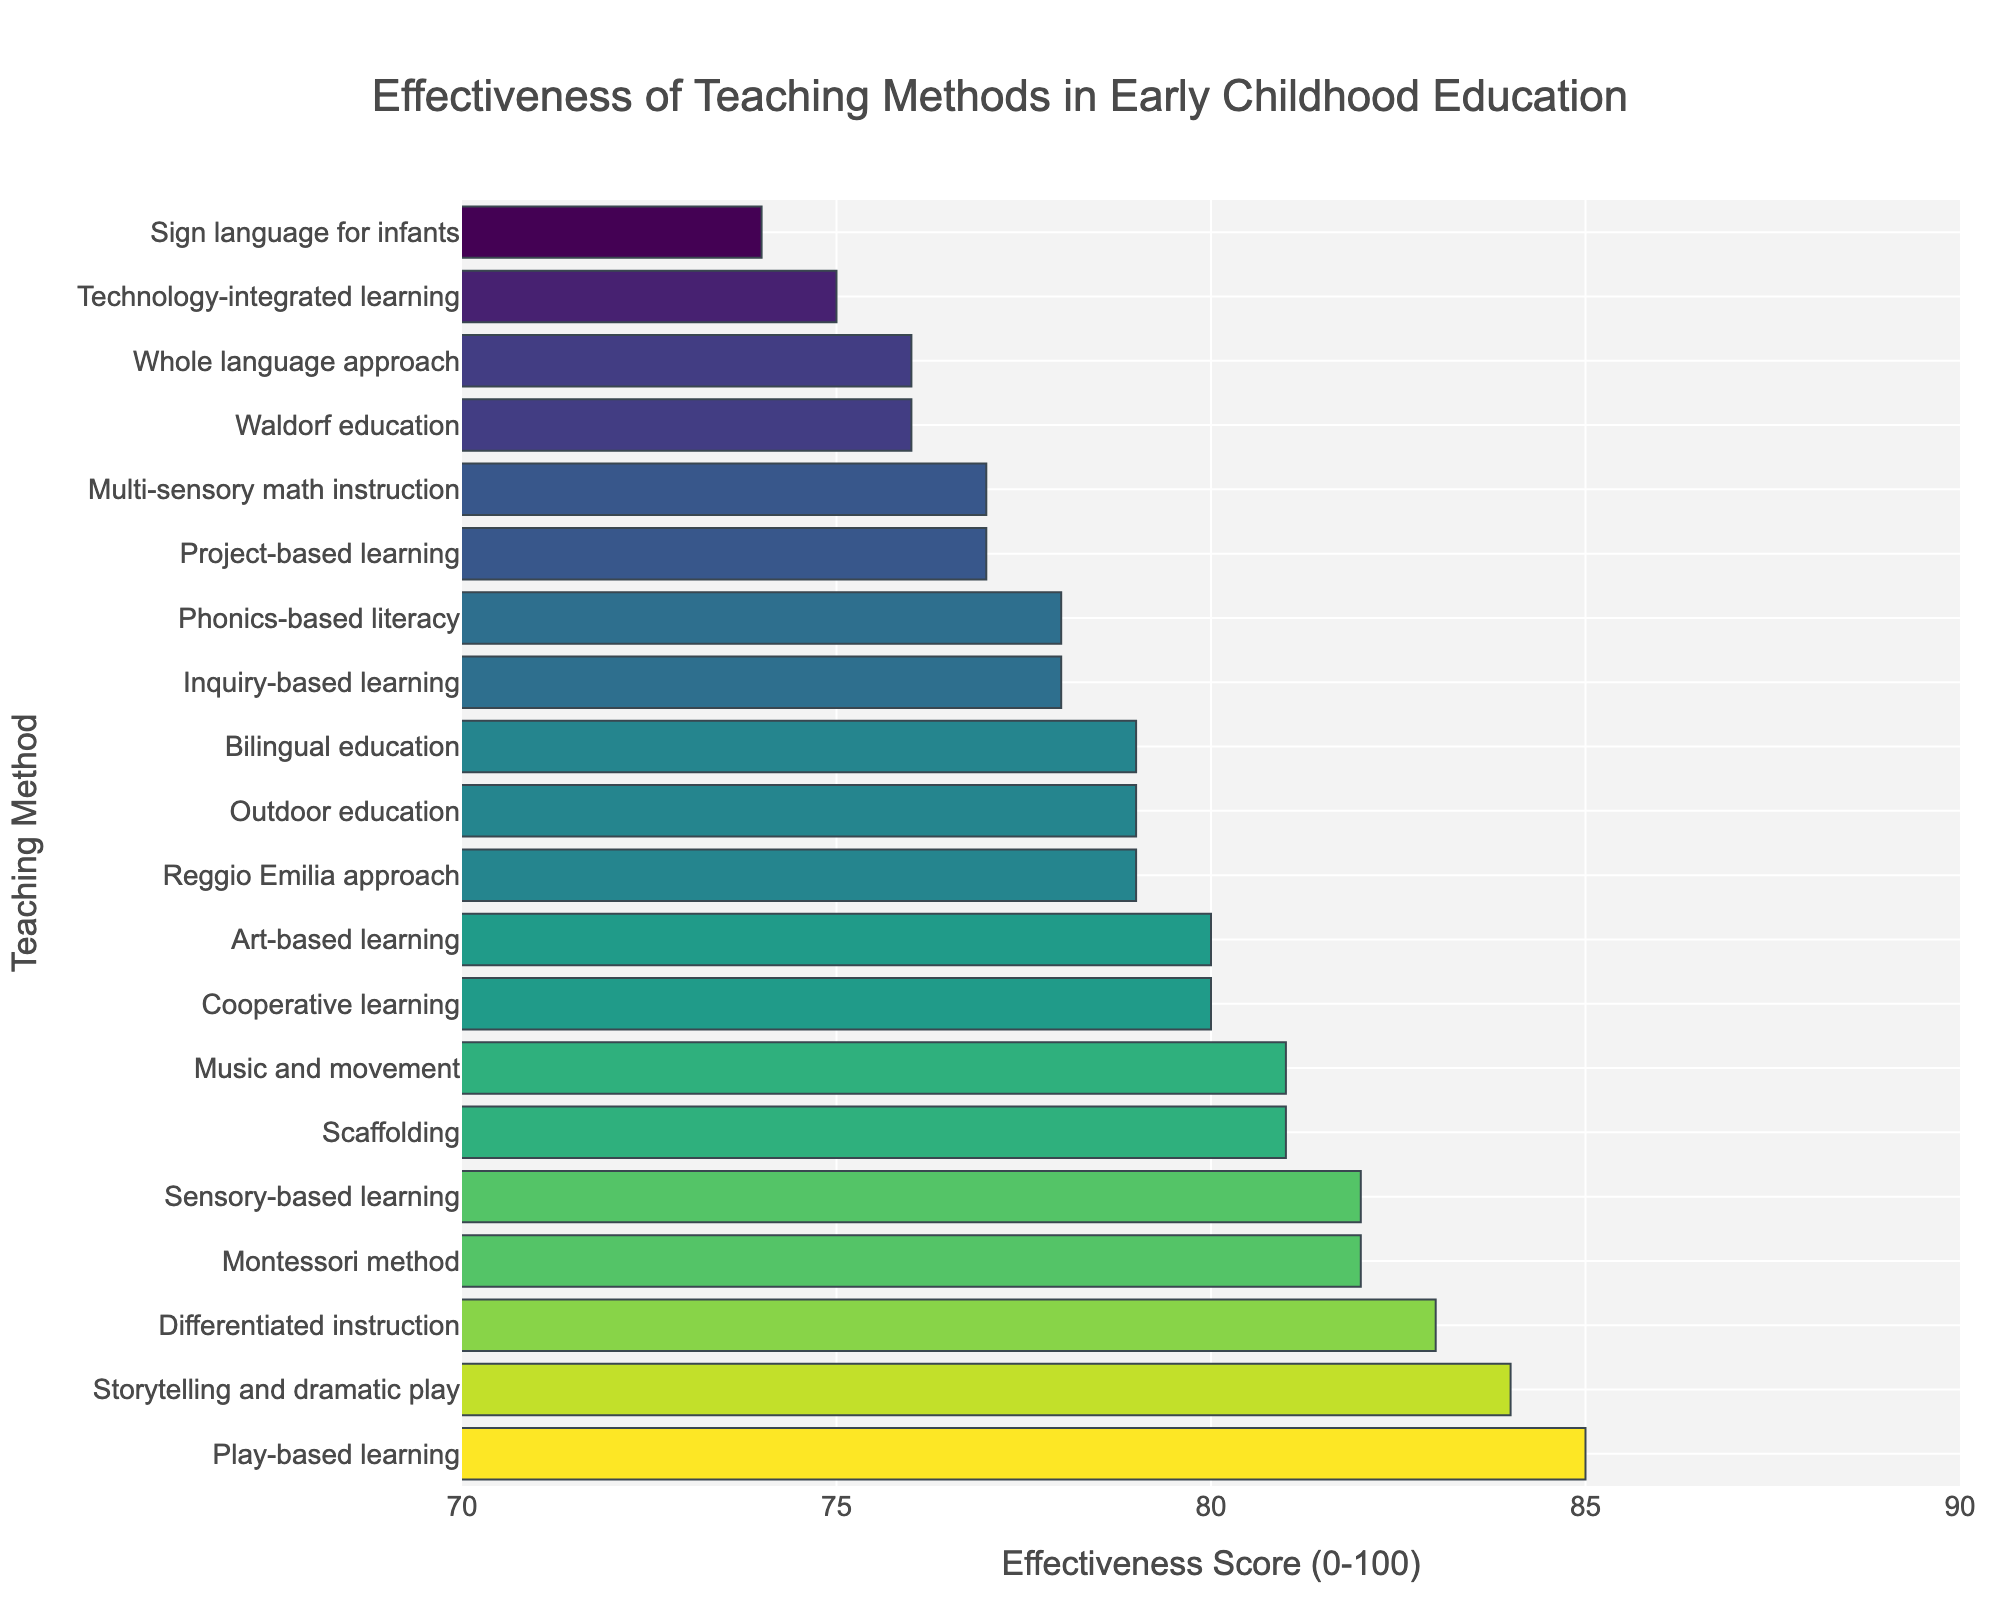What teaching method has the highest effectiveness score? The bar at the top of the chart represents the method with the highest effectiveness score. Looking at the figure, "Play-based learning" has the highest effectiveness score, visually indicated by being the longest bar at the top.
Answer: Play-based learning Which teaching method has a higher effectiveness score, "Montessori method" or "Waldorf education"? By visually comparing the lengths of the bars for "Montessori method" and "Waldorf education," we see that "Montessori method" has a longer bar with an effectiveness score of 82, while "Waldorf education" has a shorter bar with a score of 76.
Answer: Montessori method What is the combined effectiveness score of "Phonics-based literacy" and "Whole language approach"? The effectiveness score for "Phonics-based literacy" is 78, and for "Whole language approach," it is 76. Adding these together, 78 + 76 = 154.
Answer: 154 Which teaching methods have an effectiveness score below 75? Looking at the bars on the figure, "Technology-integrated learning" with a score of 75 and "Sign language for infants" with a score of 74 are the only methods below 75.
Answer: Technology-integrated learning, Sign language for infants What is the average effectiveness score of the top five teaching methods? The five highest bars represent the top five methods: "Play-based learning" (85), "Storytelling and dramatic play" (84), "Differentiated instruction" (83), "Montessori method" (82), and "Sensory-based learning" (82). The sum is 85 + 84 + 83 + 82 + 82 = 416. The average is 416 / 5 = 83.2.
Answer: 83.2 Which teaching method is more effective, "Outdoor education" or "Art-based learning," and by how much? The effectiveness score for "Outdoor education" is 79, and for "Art-based learning," it is 80. Subtracting these, 80 - 79 = 1, so "Art-based learning" is 1 point more effective than "Outdoor education."
Answer: Art-based learning by 1 Are there any teaching methods with the same effectiveness score? If so, which ones? By examining the lengths of the bars, "Montessori method" and "Sensory-based learning" both have an effectiveness score of 82, and "Scaffolding" and "Music and movement" both have scores of 81.
Answer: Montessori method and Sensory-based learning; Scaffolding and Music and movement What's the difference in effectiveness score between the highest and the lowest-rated methods? The highest effectiveness score is 85 ("Play-based learning"), and the lowest is 74 ("Sign language for infants"). The difference is 85 - 74 = 11.
Answer: 11 What is the median effectiveness score of all the teaching methods displayed? To find the median, we first list all the effectiveness scores in ascending order: 74, 75, 76, 76, 77, 77, 78, 78, 79, 79, 79, 80, 80, 81, 81, 82, 82, 83, 84, 85. There are 20 scores, so the median is the average of the 10th and 11th values: (79 + 79) / 2 = 79.
Answer: 79 